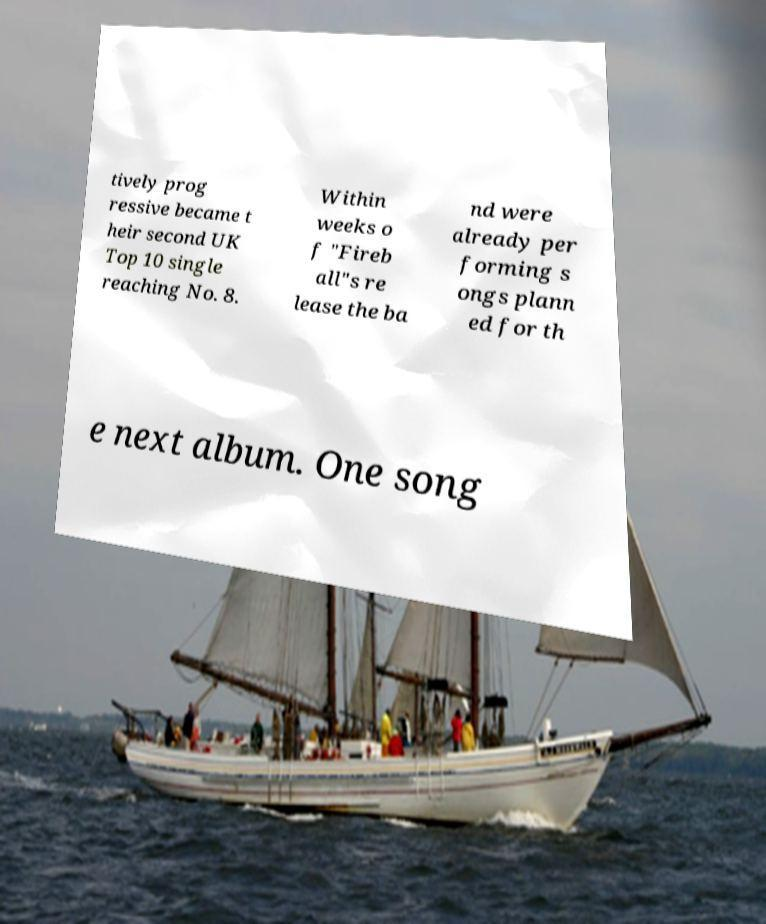Please identify and transcribe the text found in this image. tively prog ressive became t heir second UK Top 10 single reaching No. 8. Within weeks o f "Fireb all"s re lease the ba nd were already per forming s ongs plann ed for th e next album. One song 